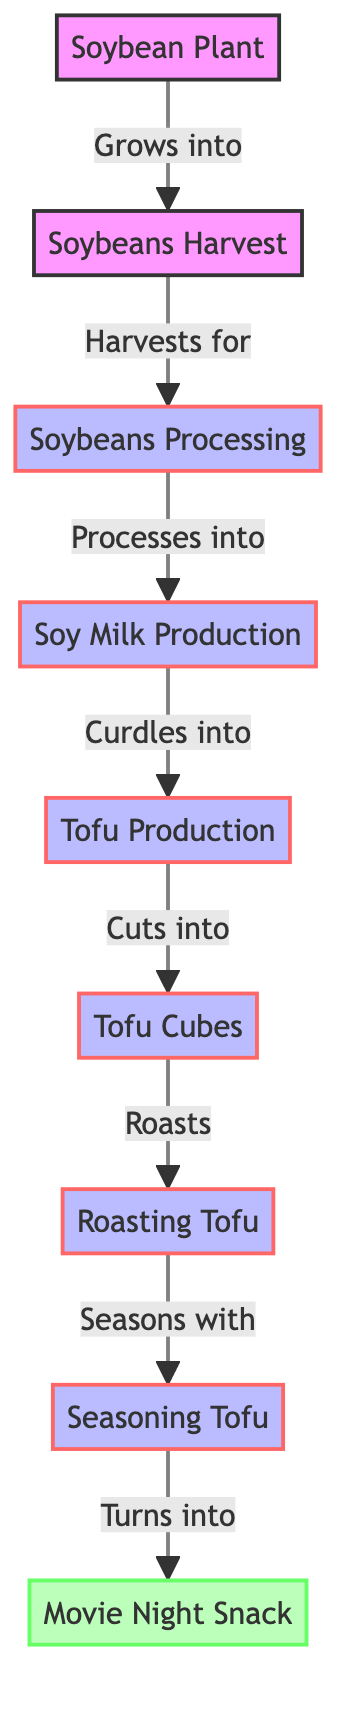What is the first node in the diagram? The first node in the diagram is the "Soybean Plant," as it is the starting point of the food chain.
Answer: Soybean Plant How many nodes are there in total? By counting each listed element in the diagram, including the final product, we find there are a total of nine nodes.
Answer: 9 What is the last product in the food chain? The last product in the diagram is "Movie Night Snack," which indicates the final output of the process.
Answer: Movie Night Snack What process follows "Tofu Production"? The process that follows "Tofu Production" is "Cuts into," which leads to "Tofu Cubes."
Answer: Cuts into What does "Tofu Cubes" turn into after roasting? After roasting, "Tofu Cubes" turns into "Roasting Tofu," indicating the next step in the process.
Answer: Roasting Tofu What relationship does "Soybeans Processing" have with "Tofu Production"? "Soybeans Processing" is an essential step before reaching "Tofu Production," as it directly leads to it by processing the soybeans into soy milk first.
Answer: Leads to How many processes are there in total? There are five processes identified in the diagram, which include "Soybeans Processing," "Soy Milk Production," "Tofu Production," "Roasting Tofu," and "Seasoning Tofu."
Answer: 5 What is the step that involves seasoning? The step that involves seasoning is "Seasons with," which leads to the final product "Movie Night Snack."
Answer: Seasons with Which node indicates the curdling process? The node that indicates the curdling process is "Curdles into," which directly relates to "Tofu Production."
Answer: Curdles into 